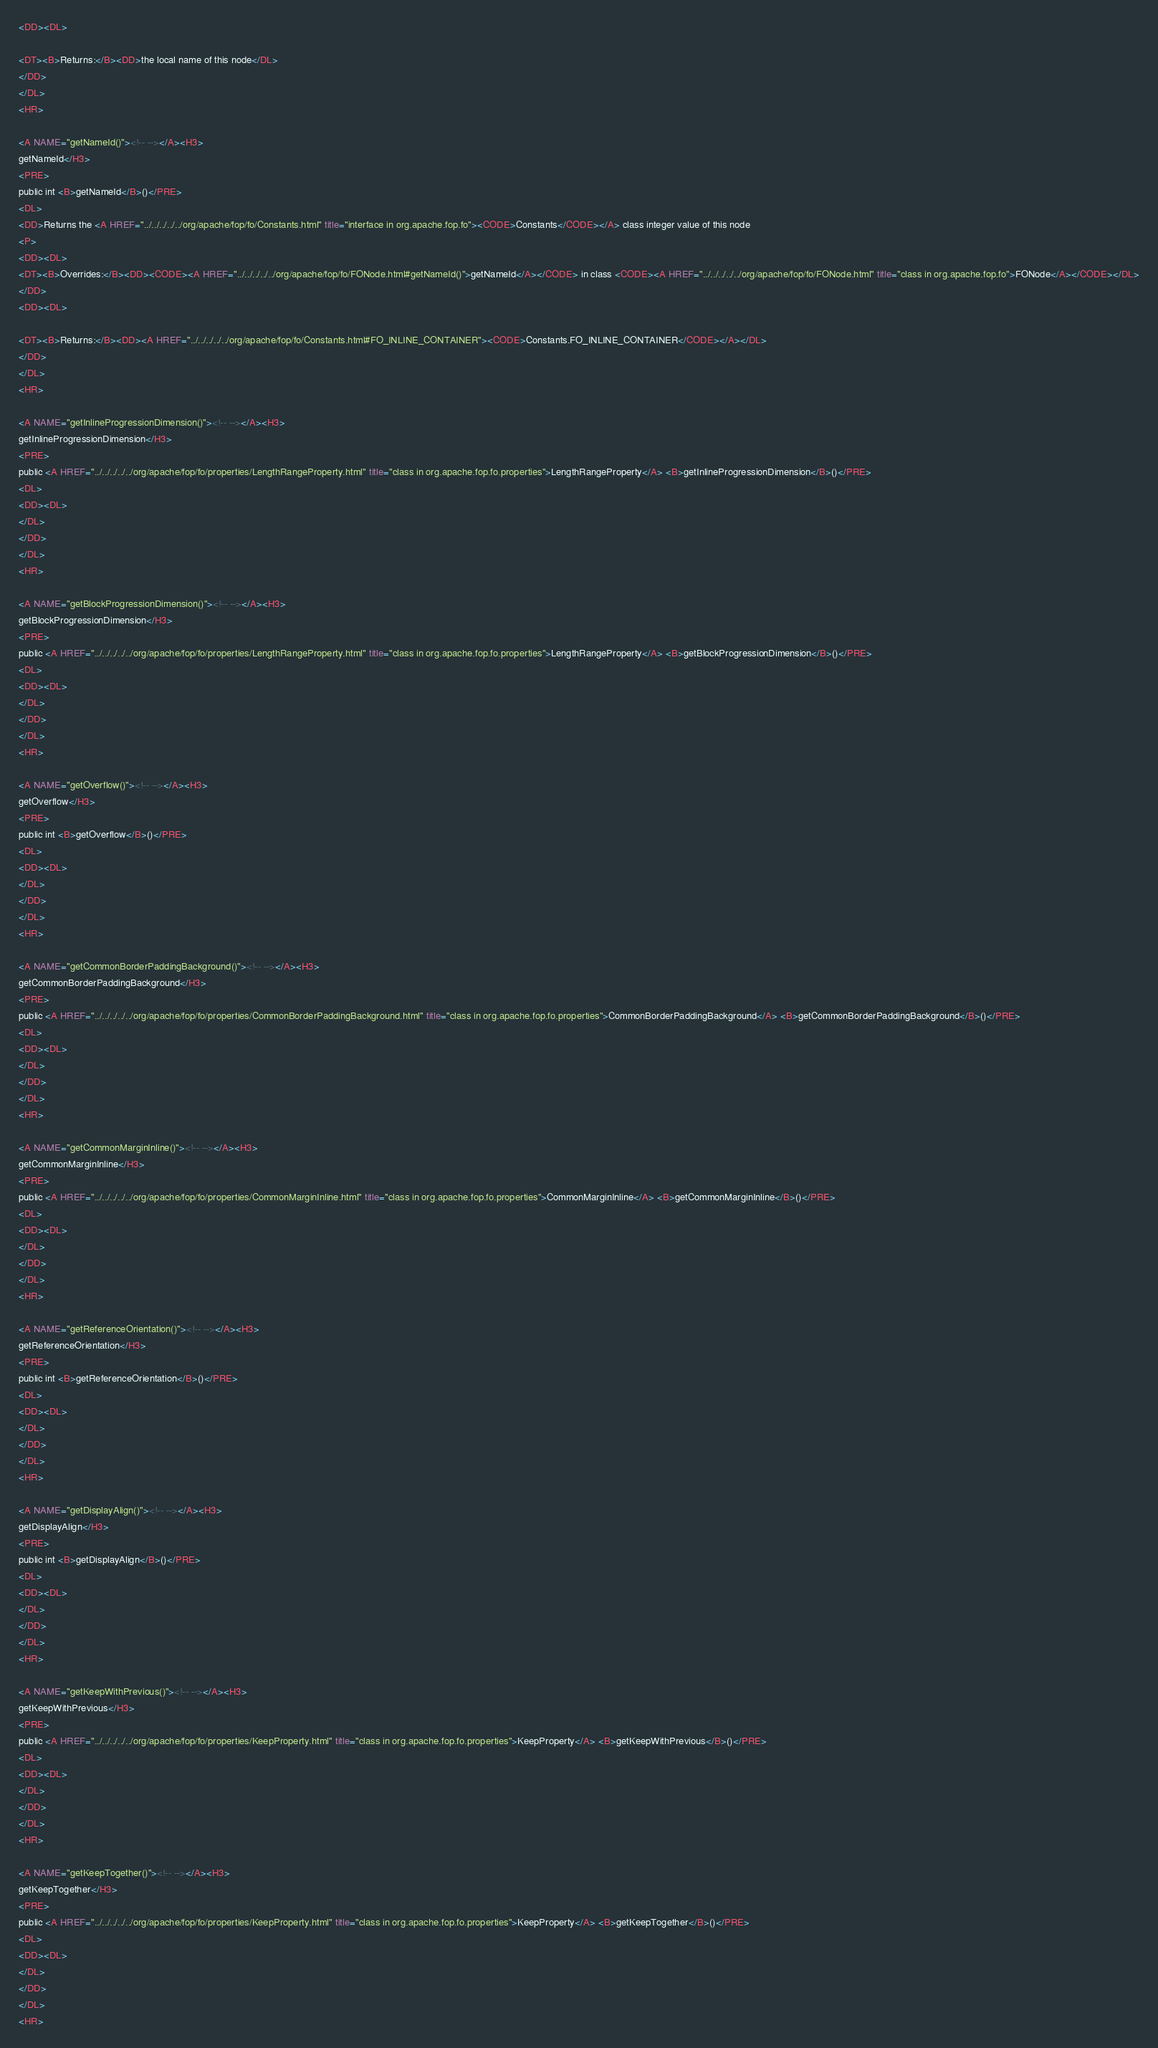Convert code to text. <code><loc_0><loc_0><loc_500><loc_500><_HTML_><DD><DL>

<DT><B>Returns:</B><DD>the local name of this node</DL>
</DD>
</DL>
<HR>

<A NAME="getNameId()"><!-- --></A><H3>
getNameId</H3>
<PRE>
public int <B>getNameId</B>()</PRE>
<DL>
<DD>Returns the <A HREF="../../../../../org/apache/fop/fo/Constants.html" title="interface in org.apache.fop.fo"><CODE>Constants</CODE></A> class integer value of this node
<P>
<DD><DL>
<DT><B>Overrides:</B><DD><CODE><A HREF="../../../../../org/apache/fop/fo/FONode.html#getNameId()">getNameId</A></CODE> in class <CODE><A HREF="../../../../../org/apache/fop/fo/FONode.html" title="class in org.apache.fop.fo">FONode</A></CODE></DL>
</DD>
<DD><DL>

<DT><B>Returns:</B><DD><A HREF="../../../../../org/apache/fop/fo/Constants.html#FO_INLINE_CONTAINER"><CODE>Constants.FO_INLINE_CONTAINER</CODE></A></DL>
</DD>
</DL>
<HR>

<A NAME="getInlineProgressionDimension()"><!-- --></A><H3>
getInlineProgressionDimension</H3>
<PRE>
public <A HREF="../../../../../org/apache/fop/fo/properties/LengthRangeProperty.html" title="class in org.apache.fop.fo.properties">LengthRangeProperty</A> <B>getInlineProgressionDimension</B>()</PRE>
<DL>
<DD><DL>
</DL>
</DD>
</DL>
<HR>

<A NAME="getBlockProgressionDimension()"><!-- --></A><H3>
getBlockProgressionDimension</H3>
<PRE>
public <A HREF="../../../../../org/apache/fop/fo/properties/LengthRangeProperty.html" title="class in org.apache.fop.fo.properties">LengthRangeProperty</A> <B>getBlockProgressionDimension</B>()</PRE>
<DL>
<DD><DL>
</DL>
</DD>
</DL>
<HR>

<A NAME="getOverflow()"><!-- --></A><H3>
getOverflow</H3>
<PRE>
public int <B>getOverflow</B>()</PRE>
<DL>
<DD><DL>
</DL>
</DD>
</DL>
<HR>

<A NAME="getCommonBorderPaddingBackground()"><!-- --></A><H3>
getCommonBorderPaddingBackground</H3>
<PRE>
public <A HREF="../../../../../org/apache/fop/fo/properties/CommonBorderPaddingBackground.html" title="class in org.apache.fop.fo.properties">CommonBorderPaddingBackground</A> <B>getCommonBorderPaddingBackground</B>()</PRE>
<DL>
<DD><DL>
</DL>
</DD>
</DL>
<HR>

<A NAME="getCommonMarginInline()"><!-- --></A><H3>
getCommonMarginInline</H3>
<PRE>
public <A HREF="../../../../../org/apache/fop/fo/properties/CommonMarginInline.html" title="class in org.apache.fop.fo.properties">CommonMarginInline</A> <B>getCommonMarginInline</B>()</PRE>
<DL>
<DD><DL>
</DL>
</DD>
</DL>
<HR>

<A NAME="getReferenceOrientation()"><!-- --></A><H3>
getReferenceOrientation</H3>
<PRE>
public int <B>getReferenceOrientation</B>()</PRE>
<DL>
<DD><DL>
</DL>
</DD>
</DL>
<HR>

<A NAME="getDisplayAlign()"><!-- --></A><H3>
getDisplayAlign</H3>
<PRE>
public int <B>getDisplayAlign</B>()</PRE>
<DL>
<DD><DL>
</DL>
</DD>
</DL>
<HR>

<A NAME="getKeepWithPrevious()"><!-- --></A><H3>
getKeepWithPrevious</H3>
<PRE>
public <A HREF="../../../../../org/apache/fop/fo/properties/KeepProperty.html" title="class in org.apache.fop.fo.properties">KeepProperty</A> <B>getKeepWithPrevious</B>()</PRE>
<DL>
<DD><DL>
</DL>
</DD>
</DL>
<HR>

<A NAME="getKeepTogether()"><!-- --></A><H3>
getKeepTogether</H3>
<PRE>
public <A HREF="../../../../../org/apache/fop/fo/properties/KeepProperty.html" title="class in org.apache.fop.fo.properties">KeepProperty</A> <B>getKeepTogether</B>()</PRE>
<DL>
<DD><DL>
</DL>
</DD>
</DL>
<HR>
</code> 